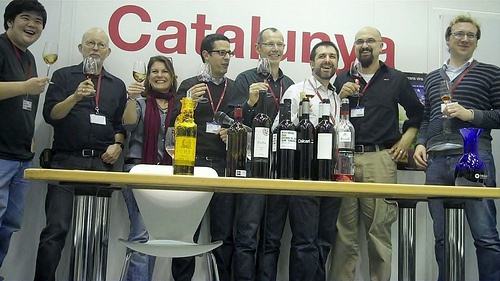Describe the objects in this image and their specific colors. I can see dining table in darkgray, black, gray, tan, and darkgreen tones, people in darkgray, black, gray, navy, and darkblue tones, people in darkgray, black, gray, and darkgreen tones, people in darkgray, black, and gray tones, and people in darkgray, black, gray, navy, and darkblue tones in this image. 